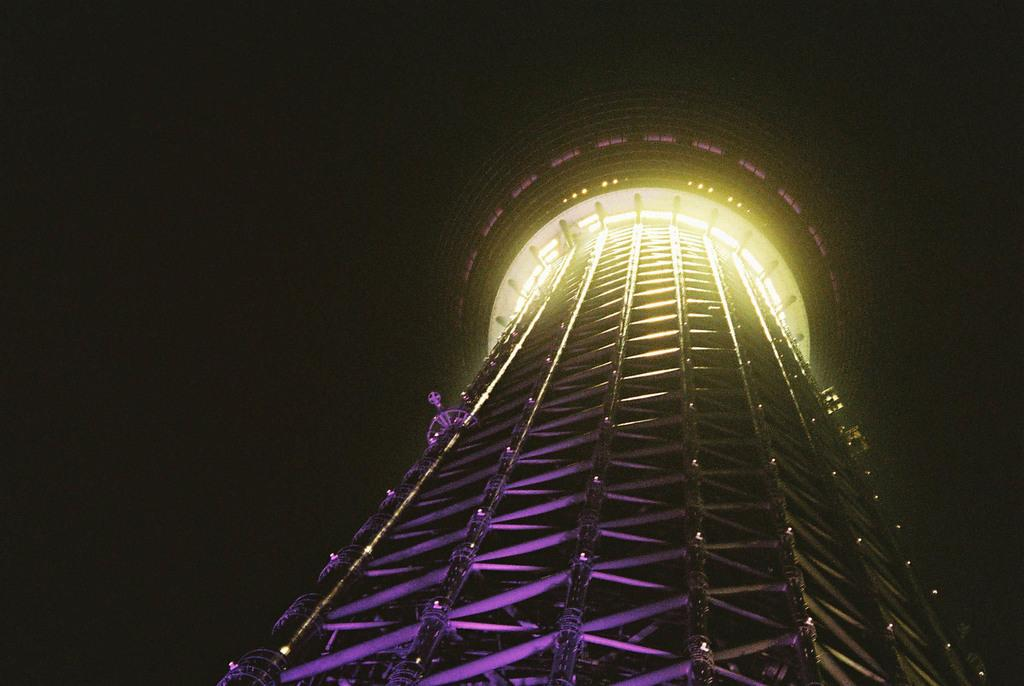What is the main subject of the image? The main subject of the image is a tower. What can be observed about the background of the image? The background of the image is dark. Is there steam coming out of the tower in the image? There is no steam present in the image; it only features a tower with a dark background. How many people are quietly standing near the tower in the image? There is no information about people or their actions in the image, as it only features a tower with a dark background. 